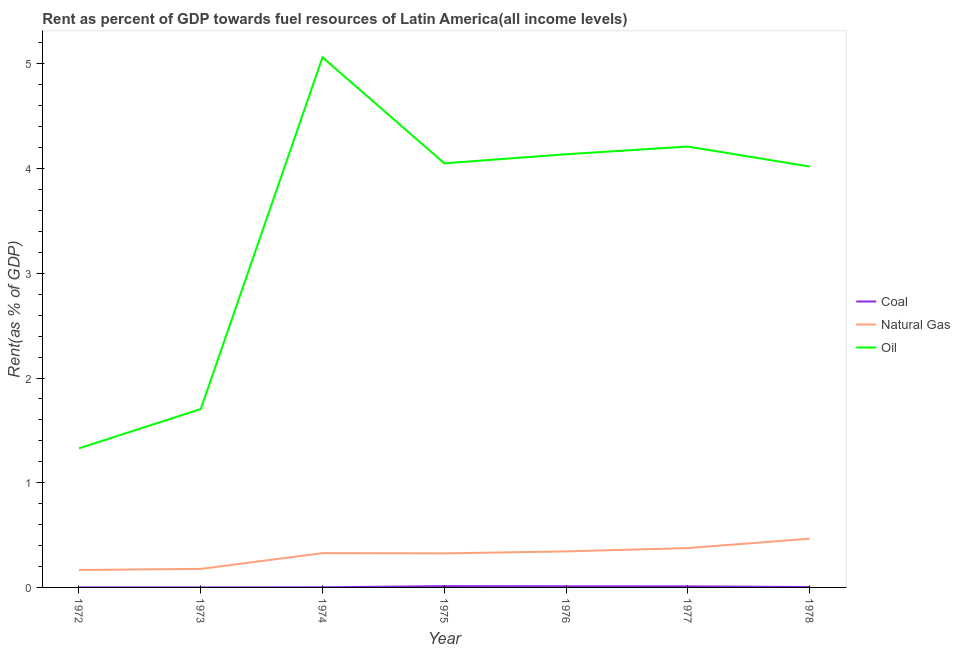Does the line corresponding to rent towards coal intersect with the line corresponding to rent towards natural gas?
Keep it short and to the point. No. Is the number of lines equal to the number of legend labels?
Your response must be concise. Yes. What is the rent towards coal in 1977?
Ensure brevity in your answer.  0.01. Across all years, what is the maximum rent towards coal?
Offer a very short reply. 0.01. Across all years, what is the minimum rent towards coal?
Give a very brief answer. 1.897656593667769e-5. In which year was the rent towards coal maximum?
Offer a very short reply. 1975. What is the total rent towards coal in the graph?
Make the answer very short. 0.04. What is the difference between the rent towards coal in 1976 and that in 1977?
Your response must be concise. 0. What is the difference between the rent towards oil in 1978 and the rent towards natural gas in 1976?
Provide a succinct answer. 3.68. What is the average rent towards oil per year?
Your answer should be very brief. 3.5. In the year 1972, what is the difference between the rent towards oil and rent towards natural gas?
Provide a short and direct response. 1.16. In how many years, is the rent towards oil greater than 1.4 %?
Your answer should be compact. 6. What is the ratio of the rent towards coal in 1974 to that in 1977?
Make the answer very short. 0.12. Is the difference between the rent towards oil in 1974 and 1975 greater than the difference between the rent towards coal in 1974 and 1975?
Ensure brevity in your answer.  Yes. What is the difference between the highest and the second highest rent towards natural gas?
Give a very brief answer. 0.09. What is the difference between the highest and the lowest rent towards oil?
Provide a succinct answer. 3.73. In how many years, is the rent towards coal greater than the average rent towards coal taken over all years?
Keep it short and to the point. 3. Is the sum of the rent towards oil in 1974 and 1975 greater than the maximum rent towards natural gas across all years?
Give a very brief answer. Yes. Is the rent towards natural gas strictly less than the rent towards oil over the years?
Make the answer very short. Yes. What is the difference between two consecutive major ticks on the Y-axis?
Provide a short and direct response. 1. Are the values on the major ticks of Y-axis written in scientific E-notation?
Provide a short and direct response. No. Does the graph contain any zero values?
Give a very brief answer. No. How many legend labels are there?
Offer a terse response. 3. What is the title of the graph?
Ensure brevity in your answer.  Rent as percent of GDP towards fuel resources of Latin America(all income levels). Does "Injury" appear as one of the legend labels in the graph?
Keep it short and to the point. No. What is the label or title of the X-axis?
Your answer should be compact. Year. What is the label or title of the Y-axis?
Your answer should be compact. Rent(as % of GDP). What is the Rent(as % of GDP) of Coal in 1972?
Give a very brief answer. 3.10850587470823e-5. What is the Rent(as % of GDP) of Natural Gas in 1972?
Make the answer very short. 0.17. What is the Rent(as % of GDP) of Oil in 1972?
Offer a terse response. 1.33. What is the Rent(as % of GDP) in Coal in 1973?
Give a very brief answer. 1.897656593667769e-5. What is the Rent(as % of GDP) in Natural Gas in 1973?
Provide a short and direct response. 0.18. What is the Rent(as % of GDP) of Oil in 1973?
Provide a short and direct response. 1.7. What is the Rent(as % of GDP) of Coal in 1974?
Your answer should be compact. 0. What is the Rent(as % of GDP) in Natural Gas in 1974?
Ensure brevity in your answer.  0.33. What is the Rent(as % of GDP) of Oil in 1974?
Keep it short and to the point. 5.06. What is the Rent(as % of GDP) in Coal in 1975?
Your answer should be compact. 0.01. What is the Rent(as % of GDP) in Natural Gas in 1975?
Offer a very short reply. 0.33. What is the Rent(as % of GDP) in Oil in 1975?
Provide a succinct answer. 4.05. What is the Rent(as % of GDP) of Coal in 1976?
Ensure brevity in your answer.  0.01. What is the Rent(as % of GDP) in Natural Gas in 1976?
Ensure brevity in your answer.  0.34. What is the Rent(as % of GDP) of Oil in 1976?
Give a very brief answer. 4.14. What is the Rent(as % of GDP) of Coal in 1977?
Keep it short and to the point. 0.01. What is the Rent(as % of GDP) in Natural Gas in 1977?
Offer a terse response. 0.38. What is the Rent(as % of GDP) in Oil in 1977?
Offer a very short reply. 4.21. What is the Rent(as % of GDP) of Coal in 1978?
Offer a terse response. 0. What is the Rent(as % of GDP) of Natural Gas in 1978?
Your answer should be compact. 0.47. What is the Rent(as % of GDP) in Oil in 1978?
Offer a very short reply. 4.02. Across all years, what is the maximum Rent(as % of GDP) of Coal?
Your answer should be very brief. 0.01. Across all years, what is the maximum Rent(as % of GDP) in Natural Gas?
Your answer should be compact. 0.47. Across all years, what is the maximum Rent(as % of GDP) of Oil?
Keep it short and to the point. 5.06. Across all years, what is the minimum Rent(as % of GDP) in Coal?
Ensure brevity in your answer.  1.897656593667769e-5. Across all years, what is the minimum Rent(as % of GDP) of Natural Gas?
Your response must be concise. 0.17. Across all years, what is the minimum Rent(as % of GDP) of Oil?
Your response must be concise. 1.33. What is the total Rent(as % of GDP) of Coal in the graph?
Provide a short and direct response. 0.04. What is the total Rent(as % of GDP) of Natural Gas in the graph?
Give a very brief answer. 2.18. What is the total Rent(as % of GDP) of Oil in the graph?
Provide a succinct answer. 24.51. What is the difference between the Rent(as % of GDP) of Coal in 1972 and that in 1973?
Your answer should be very brief. 0. What is the difference between the Rent(as % of GDP) in Natural Gas in 1972 and that in 1973?
Give a very brief answer. -0.01. What is the difference between the Rent(as % of GDP) in Oil in 1972 and that in 1973?
Your answer should be very brief. -0.38. What is the difference between the Rent(as % of GDP) of Coal in 1972 and that in 1974?
Keep it short and to the point. -0. What is the difference between the Rent(as % of GDP) in Natural Gas in 1972 and that in 1974?
Give a very brief answer. -0.16. What is the difference between the Rent(as % of GDP) of Oil in 1972 and that in 1974?
Offer a terse response. -3.73. What is the difference between the Rent(as % of GDP) of Coal in 1972 and that in 1975?
Offer a very short reply. -0.01. What is the difference between the Rent(as % of GDP) in Natural Gas in 1972 and that in 1975?
Your answer should be very brief. -0.16. What is the difference between the Rent(as % of GDP) in Oil in 1972 and that in 1975?
Your answer should be compact. -2.72. What is the difference between the Rent(as % of GDP) of Coal in 1972 and that in 1976?
Your answer should be compact. -0.01. What is the difference between the Rent(as % of GDP) in Natural Gas in 1972 and that in 1976?
Make the answer very short. -0.18. What is the difference between the Rent(as % of GDP) in Oil in 1972 and that in 1976?
Ensure brevity in your answer.  -2.81. What is the difference between the Rent(as % of GDP) of Coal in 1972 and that in 1977?
Provide a succinct answer. -0.01. What is the difference between the Rent(as % of GDP) of Natural Gas in 1972 and that in 1977?
Provide a short and direct response. -0.21. What is the difference between the Rent(as % of GDP) of Oil in 1972 and that in 1977?
Offer a terse response. -2.88. What is the difference between the Rent(as % of GDP) in Coal in 1972 and that in 1978?
Your answer should be very brief. -0. What is the difference between the Rent(as % of GDP) of Natural Gas in 1972 and that in 1978?
Offer a terse response. -0.3. What is the difference between the Rent(as % of GDP) of Oil in 1972 and that in 1978?
Your answer should be very brief. -2.69. What is the difference between the Rent(as % of GDP) of Coal in 1973 and that in 1974?
Offer a very short reply. -0. What is the difference between the Rent(as % of GDP) of Natural Gas in 1973 and that in 1974?
Provide a succinct answer. -0.15. What is the difference between the Rent(as % of GDP) of Oil in 1973 and that in 1974?
Make the answer very short. -3.36. What is the difference between the Rent(as % of GDP) of Coal in 1973 and that in 1975?
Make the answer very short. -0.01. What is the difference between the Rent(as % of GDP) of Natural Gas in 1973 and that in 1975?
Make the answer very short. -0.15. What is the difference between the Rent(as % of GDP) of Oil in 1973 and that in 1975?
Make the answer very short. -2.35. What is the difference between the Rent(as % of GDP) of Coal in 1973 and that in 1976?
Offer a very short reply. -0.01. What is the difference between the Rent(as % of GDP) in Natural Gas in 1973 and that in 1976?
Ensure brevity in your answer.  -0.17. What is the difference between the Rent(as % of GDP) in Oil in 1973 and that in 1976?
Provide a short and direct response. -2.43. What is the difference between the Rent(as % of GDP) in Coal in 1973 and that in 1977?
Make the answer very short. -0.01. What is the difference between the Rent(as % of GDP) in Natural Gas in 1973 and that in 1977?
Make the answer very short. -0.2. What is the difference between the Rent(as % of GDP) in Oil in 1973 and that in 1977?
Provide a succinct answer. -2.51. What is the difference between the Rent(as % of GDP) of Coal in 1973 and that in 1978?
Offer a terse response. -0. What is the difference between the Rent(as % of GDP) in Natural Gas in 1973 and that in 1978?
Your response must be concise. -0.29. What is the difference between the Rent(as % of GDP) of Oil in 1973 and that in 1978?
Make the answer very short. -2.32. What is the difference between the Rent(as % of GDP) of Coal in 1974 and that in 1975?
Give a very brief answer. -0.01. What is the difference between the Rent(as % of GDP) of Natural Gas in 1974 and that in 1975?
Provide a succinct answer. 0. What is the difference between the Rent(as % of GDP) of Oil in 1974 and that in 1975?
Give a very brief answer. 1.01. What is the difference between the Rent(as % of GDP) of Coal in 1974 and that in 1976?
Give a very brief answer. -0.01. What is the difference between the Rent(as % of GDP) in Natural Gas in 1974 and that in 1976?
Provide a short and direct response. -0.02. What is the difference between the Rent(as % of GDP) in Oil in 1974 and that in 1976?
Ensure brevity in your answer.  0.93. What is the difference between the Rent(as % of GDP) of Coal in 1974 and that in 1977?
Keep it short and to the point. -0.01. What is the difference between the Rent(as % of GDP) of Natural Gas in 1974 and that in 1977?
Provide a succinct answer. -0.05. What is the difference between the Rent(as % of GDP) in Oil in 1974 and that in 1977?
Your answer should be very brief. 0.85. What is the difference between the Rent(as % of GDP) in Coal in 1974 and that in 1978?
Offer a very short reply. -0. What is the difference between the Rent(as % of GDP) of Natural Gas in 1974 and that in 1978?
Give a very brief answer. -0.14. What is the difference between the Rent(as % of GDP) in Oil in 1974 and that in 1978?
Offer a terse response. 1.04. What is the difference between the Rent(as % of GDP) of Coal in 1975 and that in 1976?
Give a very brief answer. 0. What is the difference between the Rent(as % of GDP) in Natural Gas in 1975 and that in 1976?
Offer a terse response. -0.02. What is the difference between the Rent(as % of GDP) of Oil in 1975 and that in 1976?
Your answer should be very brief. -0.09. What is the difference between the Rent(as % of GDP) in Coal in 1975 and that in 1977?
Offer a very short reply. 0. What is the difference between the Rent(as % of GDP) of Natural Gas in 1975 and that in 1977?
Offer a very short reply. -0.05. What is the difference between the Rent(as % of GDP) of Oil in 1975 and that in 1977?
Ensure brevity in your answer.  -0.16. What is the difference between the Rent(as % of GDP) of Coal in 1975 and that in 1978?
Give a very brief answer. 0.01. What is the difference between the Rent(as % of GDP) of Natural Gas in 1975 and that in 1978?
Keep it short and to the point. -0.14. What is the difference between the Rent(as % of GDP) of Oil in 1975 and that in 1978?
Your response must be concise. 0.03. What is the difference between the Rent(as % of GDP) in Coal in 1976 and that in 1977?
Your response must be concise. 0. What is the difference between the Rent(as % of GDP) in Natural Gas in 1976 and that in 1977?
Provide a short and direct response. -0.03. What is the difference between the Rent(as % of GDP) in Oil in 1976 and that in 1977?
Make the answer very short. -0.07. What is the difference between the Rent(as % of GDP) of Coal in 1976 and that in 1978?
Provide a short and direct response. 0.01. What is the difference between the Rent(as % of GDP) of Natural Gas in 1976 and that in 1978?
Provide a succinct answer. -0.12. What is the difference between the Rent(as % of GDP) in Oil in 1976 and that in 1978?
Your response must be concise. 0.12. What is the difference between the Rent(as % of GDP) of Coal in 1977 and that in 1978?
Ensure brevity in your answer.  0.01. What is the difference between the Rent(as % of GDP) of Natural Gas in 1977 and that in 1978?
Provide a succinct answer. -0.09. What is the difference between the Rent(as % of GDP) in Oil in 1977 and that in 1978?
Offer a very short reply. 0.19. What is the difference between the Rent(as % of GDP) of Coal in 1972 and the Rent(as % of GDP) of Natural Gas in 1973?
Ensure brevity in your answer.  -0.18. What is the difference between the Rent(as % of GDP) in Coal in 1972 and the Rent(as % of GDP) in Oil in 1973?
Your answer should be compact. -1.7. What is the difference between the Rent(as % of GDP) in Natural Gas in 1972 and the Rent(as % of GDP) in Oil in 1973?
Offer a very short reply. -1.54. What is the difference between the Rent(as % of GDP) of Coal in 1972 and the Rent(as % of GDP) of Natural Gas in 1974?
Keep it short and to the point. -0.33. What is the difference between the Rent(as % of GDP) of Coal in 1972 and the Rent(as % of GDP) of Oil in 1974?
Give a very brief answer. -5.06. What is the difference between the Rent(as % of GDP) in Natural Gas in 1972 and the Rent(as % of GDP) in Oil in 1974?
Your answer should be compact. -4.9. What is the difference between the Rent(as % of GDP) in Coal in 1972 and the Rent(as % of GDP) in Natural Gas in 1975?
Your answer should be very brief. -0.33. What is the difference between the Rent(as % of GDP) of Coal in 1972 and the Rent(as % of GDP) of Oil in 1975?
Your answer should be very brief. -4.05. What is the difference between the Rent(as % of GDP) of Natural Gas in 1972 and the Rent(as % of GDP) of Oil in 1975?
Make the answer very short. -3.88. What is the difference between the Rent(as % of GDP) of Coal in 1972 and the Rent(as % of GDP) of Natural Gas in 1976?
Your answer should be compact. -0.34. What is the difference between the Rent(as % of GDP) of Coal in 1972 and the Rent(as % of GDP) of Oil in 1976?
Offer a very short reply. -4.14. What is the difference between the Rent(as % of GDP) of Natural Gas in 1972 and the Rent(as % of GDP) of Oil in 1976?
Provide a short and direct response. -3.97. What is the difference between the Rent(as % of GDP) in Coal in 1972 and the Rent(as % of GDP) in Natural Gas in 1977?
Your answer should be compact. -0.38. What is the difference between the Rent(as % of GDP) of Coal in 1972 and the Rent(as % of GDP) of Oil in 1977?
Ensure brevity in your answer.  -4.21. What is the difference between the Rent(as % of GDP) in Natural Gas in 1972 and the Rent(as % of GDP) in Oil in 1977?
Provide a short and direct response. -4.04. What is the difference between the Rent(as % of GDP) in Coal in 1972 and the Rent(as % of GDP) in Natural Gas in 1978?
Offer a very short reply. -0.47. What is the difference between the Rent(as % of GDP) in Coal in 1972 and the Rent(as % of GDP) in Oil in 1978?
Ensure brevity in your answer.  -4.02. What is the difference between the Rent(as % of GDP) in Natural Gas in 1972 and the Rent(as % of GDP) in Oil in 1978?
Your response must be concise. -3.85. What is the difference between the Rent(as % of GDP) of Coal in 1973 and the Rent(as % of GDP) of Natural Gas in 1974?
Keep it short and to the point. -0.33. What is the difference between the Rent(as % of GDP) in Coal in 1973 and the Rent(as % of GDP) in Oil in 1974?
Give a very brief answer. -5.06. What is the difference between the Rent(as % of GDP) in Natural Gas in 1973 and the Rent(as % of GDP) in Oil in 1974?
Your answer should be very brief. -4.89. What is the difference between the Rent(as % of GDP) of Coal in 1973 and the Rent(as % of GDP) of Natural Gas in 1975?
Your response must be concise. -0.33. What is the difference between the Rent(as % of GDP) in Coal in 1973 and the Rent(as % of GDP) in Oil in 1975?
Provide a succinct answer. -4.05. What is the difference between the Rent(as % of GDP) of Natural Gas in 1973 and the Rent(as % of GDP) of Oil in 1975?
Your response must be concise. -3.87. What is the difference between the Rent(as % of GDP) in Coal in 1973 and the Rent(as % of GDP) in Natural Gas in 1976?
Offer a terse response. -0.34. What is the difference between the Rent(as % of GDP) of Coal in 1973 and the Rent(as % of GDP) of Oil in 1976?
Your answer should be very brief. -4.14. What is the difference between the Rent(as % of GDP) of Natural Gas in 1973 and the Rent(as % of GDP) of Oil in 1976?
Your answer should be compact. -3.96. What is the difference between the Rent(as % of GDP) in Coal in 1973 and the Rent(as % of GDP) in Natural Gas in 1977?
Offer a very short reply. -0.38. What is the difference between the Rent(as % of GDP) in Coal in 1973 and the Rent(as % of GDP) in Oil in 1977?
Your response must be concise. -4.21. What is the difference between the Rent(as % of GDP) in Natural Gas in 1973 and the Rent(as % of GDP) in Oil in 1977?
Make the answer very short. -4.03. What is the difference between the Rent(as % of GDP) of Coal in 1973 and the Rent(as % of GDP) of Natural Gas in 1978?
Your answer should be compact. -0.47. What is the difference between the Rent(as % of GDP) of Coal in 1973 and the Rent(as % of GDP) of Oil in 1978?
Ensure brevity in your answer.  -4.02. What is the difference between the Rent(as % of GDP) of Natural Gas in 1973 and the Rent(as % of GDP) of Oil in 1978?
Give a very brief answer. -3.84. What is the difference between the Rent(as % of GDP) of Coal in 1974 and the Rent(as % of GDP) of Natural Gas in 1975?
Give a very brief answer. -0.32. What is the difference between the Rent(as % of GDP) in Coal in 1974 and the Rent(as % of GDP) in Oil in 1975?
Your answer should be very brief. -4.05. What is the difference between the Rent(as % of GDP) of Natural Gas in 1974 and the Rent(as % of GDP) of Oil in 1975?
Ensure brevity in your answer.  -3.72. What is the difference between the Rent(as % of GDP) of Coal in 1974 and the Rent(as % of GDP) of Natural Gas in 1976?
Offer a very short reply. -0.34. What is the difference between the Rent(as % of GDP) in Coal in 1974 and the Rent(as % of GDP) in Oil in 1976?
Your answer should be very brief. -4.14. What is the difference between the Rent(as % of GDP) in Natural Gas in 1974 and the Rent(as % of GDP) in Oil in 1976?
Your response must be concise. -3.81. What is the difference between the Rent(as % of GDP) of Coal in 1974 and the Rent(as % of GDP) of Natural Gas in 1977?
Ensure brevity in your answer.  -0.37. What is the difference between the Rent(as % of GDP) of Coal in 1974 and the Rent(as % of GDP) of Oil in 1977?
Your response must be concise. -4.21. What is the difference between the Rent(as % of GDP) of Natural Gas in 1974 and the Rent(as % of GDP) of Oil in 1977?
Your answer should be very brief. -3.88. What is the difference between the Rent(as % of GDP) of Coal in 1974 and the Rent(as % of GDP) of Natural Gas in 1978?
Provide a succinct answer. -0.46. What is the difference between the Rent(as % of GDP) of Coal in 1974 and the Rent(as % of GDP) of Oil in 1978?
Provide a succinct answer. -4.02. What is the difference between the Rent(as % of GDP) in Natural Gas in 1974 and the Rent(as % of GDP) in Oil in 1978?
Make the answer very short. -3.69. What is the difference between the Rent(as % of GDP) of Coal in 1975 and the Rent(as % of GDP) of Natural Gas in 1976?
Offer a terse response. -0.33. What is the difference between the Rent(as % of GDP) of Coal in 1975 and the Rent(as % of GDP) of Oil in 1976?
Provide a succinct answer. -4.12. What is the difference between the Rent(as % of GDP) in Natural Gas in 1975 and the Rent(as % of GDP) in Oil in 1976?
Provide a succinct answer. -3.81. What is the difference between the Rent(as % of GDP) of Coal in 1975 and the Rent(as % of GDP) of Natural Gas in 1977?
Your answer should be very brief. -0.36. What is the difference between the Rent(as % of GDP) of Coal in 1975 and the Rent(as % of GDP) of Oil in 1977?
Keep it short and to the point. -4.2. What is the difference between the Rent(as % of GDP) of Natural Gas in 1975 and the Rent(as % of GDP) of Oil in 1977?
Give a very brief answer. -3.89. What is the difference between the Rent(as % of GDP) of Coal in 1975 and the Rent(as % of GDP) of Natural Gas in 1978?
Keep it short and to the point. -0.45. What is the difference between the Rent(as % of GDP) in Coal in 1975 and the Rent(as % of GDP) in Oil in 1978?
Your answer should be compact. -4.01. What is the difference between the Rent(as % of GDP) of Natural Gas in 1975 and the Rent(as % of GDP) of Oil in 1978?
Ensure brevity in your answer.  -3.69. What is the difference between the Rent(as % of GDP) in Coal in 1976 and the Rent(as % of GDP) in Natural Gas in 1977?
Give a very brief answer. -0.36. What is the difference between the Rent(as % of GDP) in Coal in 1976 and the Rent(as % of GDP) in Oil in 1977?
Your response must be concise. -4.2. What is the difference between the Rent(as % of GDP) in Natural Gas in 1976 and the Rent(as % of GDP) in Oil in 1977?
Give a very brief answer. -3.87. What is the difference between the Rent(as % of GDP) in Coal in 1976 and the Rent(as % of GDP) in Natural Gas in 1978?
Provide a short and direct response. -0.45. What is the difference between the Rent(as % of GDP) of Coal in 1976 and the Rent(as % of GDP) of Oil in 1978?
Your answer should be very brief. -4.01. What is the difference between the Rent(as % of GDP) in Natural Gas in 1976 and the Rent(as % of GDP) in Oil in 1978?
Offer a very short reply. -3.68. What is the difference between the Rent(as % of GDP) of Coal in 1977 and the Rent(as % of GDP) of Natural Gas in 1978?
Offer a very short reply. -0.45. What is the difference between the Rent(as % of GDP) of Coal in 1977 and the Rent(as % of GDP) of Oil in 1978?
Your answer should be compact. -4.01. What is the difference between the Rent(as % of GDP) of Natural Gas in 1977 and the Rent(as % of GDP) of Oil in 1978?
Offer a very short reply. -3.64. What is the average Rent(as % of GDP) in Coal per year?
Ensure brevity in your answer.  0.01. What is the average Rent(as % of GDP) of Natural Gas per year?
Offer a terse response. 0.31. What is the average Rent(as % of GDP) in Oil per year?
Ensure brevity in your answer.  3.5. In the year 1972, what is the difference between the Rent(as % of GDP) in Coal and Rent(as % of GDP) in Natural Gas?
Keep it short and to the point. -0.17. In the year 1972, what is the difference between the Rent(as % of GDP) in Coal and Rent(as % of GDP) in Oil?
Offer a very short reply. -1.33. In the year 1972, what is the difference between the Rent(as % of GDP) in Natural Gas and Rent(as % of GDP) in Oil?
Provide a short and direct response. -1.16. In the year 1973, what is the difference between the Rent(as % of GDP) in Coal and Rent(as % of GDP) in Natural Gas?
Offer a very short reply. -0.18. In the year 1973, what is the difference between the Rent(as % of GDP) of Coal and Rent(as % of GDP) of Oil?
Your answer should be compact. -1.7. In the year 1973, what is the difference between the Rent(as % of GDP) of Natural Gas and Rent(as % of GDP) of Oil?
Your answer should be very brief. -1.53. In the year 1974, what is the difference between the Rent(as % of GDP) of Coal and Rent(as % of GDP) of Natural Gas?
Keep it short and to the point. -0.33. In the year 1974, what is the difference between the Rent(as % of GDP) of Coal and Rent(as % of GDP) of Oil?
Make the answer very short. -5.06. In the year 1974, what is the difference between the Rent(as % of GDP) of Natural Gas and Rent(as % of GDP) of Oil?
Provide a succinct answer. -4.74. In the year 1975, what is the difference between the Rent(as % of GDP) of Coal and Rent(as % of GDP) of Natural Gas?
Your answer should be compact. -0.31. In the year 1975, what is the difference between the Rent(as % of GDP) in Coal and Rent(as % of GDP) in Oil?
Your answer should be very brief. -4.04. In the year 1975, what is the difference between the Rent(as % of GDP) in Natural Gas and Rent(as % of GDP) in Oil?
Your response must be concise. -3.73. In the year 1976, what is the difference between the Rent(as % of GDP) in Coal and Rent(as % of GDP) in Natural Gas?
Keep it short and to the point. -0.33. In the year 1976, what is the difference between the Rent(as % of GDP) of Coal and Rent(as % of GDP) of Oil?
Ensure brevity in your answer.  -4.13. In the year 1976, what is the difference between the Rent(as % of GDP) of Natural Gas and Rent(as % of GDP) of Oil?
Your answer should be very brief. -3.79. In the year 1977, what is the difference between the Rent(as % of GDP) of Coal and Rent(as % of GDP) of Natural Gas?
Provide a succinct answer. -0.37. In the year 1977, what is the difference between the Rent(as % of GDP) in Coal and Rent(as % of GDP) in Oil?
Make the answer very short. -4.2. In the year 1977, what is the difference between the Rent(as % of GDP) in Natural Gas and Rent(as % of GDP) in Oil?
Keep it short and to the point. -3.83. In the year 1978, what is the difference between the Rent(as % of GDP) in Coal and Rent(as % of GDP) in Natural Gas?
Keep it short and to the point. -0.46. In the year 1978, what is the difference between the Rent(as % of GDP) of Coal and Rent(as % of GDP) of Oil?
Provide a short and direct response. -4.02. In the year 1978, what is the difference between the Rent(as % of GDP) in Natural Gas and Rent(as % of GDP) in Oil?
Provide a short and direct response. -3.55. What is the ratio of the Rent(as % of GDP) in Coal in 1972 to that in 1973?
Keep it short and to the point. 1.64. What is the ratio of the Rent(as % of GDP) of Natural Gas in 1972 to that in 1973?
Your answer should be very brief. 0.94. What is the ratio of the Rent(as % of GDP) of Oil in 1972 to that in 1973?
Your response must be concise. 0.78. What is the ratio of the Rent(as % of GDP) in Coal in 1972 to that in 1974?
Ensure brevity in your answer.  0.03. What is the ratio of the Rent(as % of GDP) in Natural Gas in 1972 to that in 1974?
Ensure brevity in your answer.  0.51. What is the ratio of the Rent(as % of GDP) in Oil in 1972 to that in 1974?
Your response must be concise. 0.26. What is the ratio of the Rent(as % of GDP) of Coal in 1972 to that in 1975?
Provide a succinct answer. 0. What is the ratio of the Rent(as % of GDP) in Natural Gas in 1972 to that in 1975?
Your answer should be very brief. 0.51. What is the ratio of the Rent(as % of GDP) of Oil in 1972 to that in 1975?
Offer a very short reply. 0.33. What is the ratio of the Rent(as % of GDP) in Coal in 1972 to that in 1976?
Your answer should be very brief. 0. What is the ratio of the Rent(as % of GDP) in Natural Gas in 1972 to that in 1976?
Ensure brevity in your answer.  0.48. What is the ratio of the Rent(as % of GDP) in Oil in 1972 to that in 1976?
Your answer should be very brief. 0.32. What is the ratio of the Rent(as % of GDP) of Coal in 1972 to that in 1977?
Your answer should be compact. 0. What is the ratio of the Rent(as % of GDP) of Natural Gas in 1972 to that in 1977?
Your answer should be very brief. 0.44. What is the ratio of the Rent(as % of GDP) of Oil in 1972 to that in 1977?
Your response must be concise. 0.32. What is the ratio of the Rent(as % of GDP) of Coal in 1972 to that in 1978?
Provide a succinct answer. 0.01. What is the ratio of the Rent(as % of GDP) in Natural Gas in 1972 to that in 1978?
Offer a very short reply. 0.36. What is the ratio of the Rent(as % of GDP) of Oil in 1972 to that in 1978?
Your response must be concise. 0.33. What is the ratio of the Rent(as % of GDP) of Coal in 1973 to that in 1974?
Provide a short and direct response. 0.02. What is the ratio of the Rent(as % of GDP) in Natural Gas in 1973 to that in 1974?
Offer a terse response. 0.54. What is the ratio of the Rent(as % of GDP) of Oil in 1973 to that in 1974?
Offer a terse response. 0.34. What is the ratio of the Rent(as % of GDP) of Coal in 1973 to that in 1975?
Provide a succinct answer. 0. What is the ratio of the Rent(as % of GDP) of Natural Gas in 1973 to that in 1975?
Keep it short and to the point. 0.54. What is the ratio of the Rent(as % of GDP) in Oil in 1973 to that in 1975?
Give a very brief answer. 0.42. What is the ratio of the Rent(as % of GDP) of Coal in 1973 to that in 1976?
Provide a succinct answer. 0. What is the ratio of the Rent(as % of GDP) of Natural Gas in 1973 to that in 1976?
Your response must be concise. 0.51. What is the ratio of the Rent(as % of GDP) of Oil in 1973 to that in 1976?
Offer a terse response. 0.41. What is the ratio of the Rent(as % of GDP) of Coal in 1973 to that in 1977?
Keep it short and to the point. 0. What is the ratio of the Rent(as % of GDP) of Natural Gas in 1973 to that in 1977?
Keep it short and to the point. 0.47. What is the ratio of the Rent(as % of GDP) in Oil in 1973 to that in 1977?
Offer a very short reply. 0.4. What is the ratio of the Rent(as % of GDP) of Coal in 1973 to that in 1978?
Give a very brief answer. 0.01. What is the ratio of the Rent(as % of GDP) in Natural Gas in 1973 to that in 1978?
Keep it short and to the point. 0.38. What is the ratio of the Rent(as % of GDP) of Oil in 1973 to that in 1978?
Offer a very short reply. 0.42. What is the ratio of the Rent(as % of GDP) in Coal in 1974 to that in 1975?
Make the answer very short. 0.1. What is the ratio of the Rent(as % of GDP) of Natural Gas in 1974 to that in 1975?
Ensure brevity in your answer.  1.01. What is the ratio of the Rent(as % of GDP) in Oil in 1974 to that in 1975?
Give a very brief answer. 1.25. What is the ratio of the Rent(as % of GDP) of Coal in 1974 to that in 1976?
Your response must be concise. 0.11. What is the ratio of the Rent(as % of GDP) of Natural Gas in 1974 to that in 1976?
Your response must be concise. 0.95. What is the ratio of the Rent(as % of GDP) in Oil in 1974 to that in 1976?
Your response must be concise. 1.22. What is the ratio of the Rent(as % of GDP) of Coal in 1974 to that in 1977?
Offer a very short reply. 0.12. What is the ratio of the Rent(as % of GDP) in Natural Gas in 1974 to that in 1977?
Your answer should be very brief. 0.87. What is the ratio of the Rent(as % of GDP) in Oil in 1974 to that in 1977?
Give a very brief answer. 1.2. What is the ratio of the Rent(as % of GDP) in Coal in 1974 to that in 1978?
Give a very brief answer. 0.34. What is the ratio of the Rent(as % of GDP) in Natural Gas in 1974 to that in 1978?
Keep it short and to the point. 0.7. What is the ratio of the Rent(as % of GDP) of Oil in 1974 to that in 1978?
Provide a short and direct response. 1.26. What is the ratio of the Rent(as % of GDP) of Coal in 1975 to that in 1976?
Provide a short and direct response. 1.16. What is the ratio of the Rent(as % of GDP) in Natural Gas in 1975 to that in 1976?
Offer a terse response. 0.94. What is the ratio of the Rent(as % of GDP) of Oil in 1975 to that in 1976?
Your answer should be compact. 0.98. What is the ratio of the Rent(as % of GDP) in Coal in 1975 to that in 1977?
Offer a very short reply. 1.19. What is the ratio of the Rent(as % of GDP) of Natural Gas in 1975 to that in 1977?
Offer a very short reply. 0.86. What is the ratio of the Rent(as % of GDP) in Oil in 1975 to that in 1977?
Offer a terse response. 0.96. What is the ratio of the Rent(as % of GDP) in Coal in 1975 to that in 1978?
Ensure brevity in your answer.  3.45. What is the ratio of the Rent(as % of GDP) of Natural Gas in 1975 to that in 1978?
Your response must be concise. 0.7. What is the ratio of the Rent(as % of GDP) of Oil in 1975 to that in 1978?
Your answer should be compact. 1.01. What is the ratio of the Rent(as % of GDP) of Coal in 1976 to that in 1977?
Your answer should be very brief. 1.03. What is the ratio of the Rent(as % of GDP) in Natural Gas in 1976 to that in 1977?
Your answer should be very brief. 0.92. What is the ratio of the Rent(as % of GDP) of Oil in 1976 to that in 1977?
Your response must be concise. 0.98. What is the ratio of the Rent(as % of GDP) in Coal in 1976 to that in 1978?
Ensure brevity in your answer.  2.99. What is the ratio of the Rent(as % of GDP) of Natural Gas in 1976 to that in 1978?
Provide a short and direct response. 0.74. What is the ratio of the Rent(as % of GDP) of Oil in 1976 to that in 1978?
Provide a short and direct response. 1.03. What is the ratio of the Rent(as % of GDP) of Coal in 1977 to that in 1978?
Ensure brevity in your answer.  2.91. What is the ratio of the Rent(as % of GDP) of Natural Gas in 1977 to that in 1978?
Your response must be concise. 0.81. What is the ratio of the Rent(as % of GDP) in Oil in 1977 to that in 1978?
Offer a very short reply. 1.05. What is the difference between the highest and the second highest Rent(as % of GDP) of Coal?
Give a very brief answer. 0. What is the difference between the highest and the second highest Rent(as % of GDP) in Natural Gas?
Your response must be concise. 0.09. What is the difference between the highest and the second highest Rent(as % of GDP) of Oil?
Your response must be concise. 0.85. What is the difference between the highest and the lowest Rent(as % of GDP) of Coal?
Provide a short and direct response. 0.01. What is the difference between the highest and the lowest Rent(as % of GDP) of Natural Gas?
Your answer should be compact. 0.3. What is the difference between the highest and the lowest Rent(as % of GDP) in Oil?
Your answer should be very brief. 3.73. 